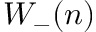Convert formula to latex. <formula><loc_0><loc_0><loc_500><loc_500>W _ { - } ( n )</formula> 